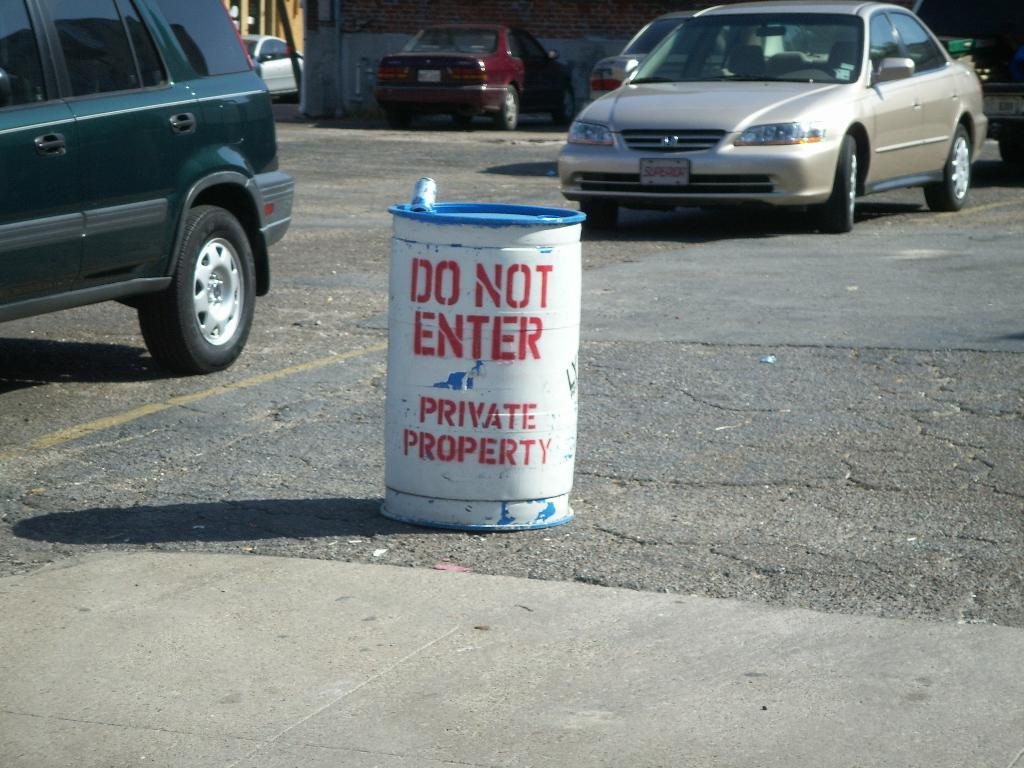<image>
Render a clear and concise summary of the photo. A "do not enter" sign is printed on a barrel in a parking lot. 